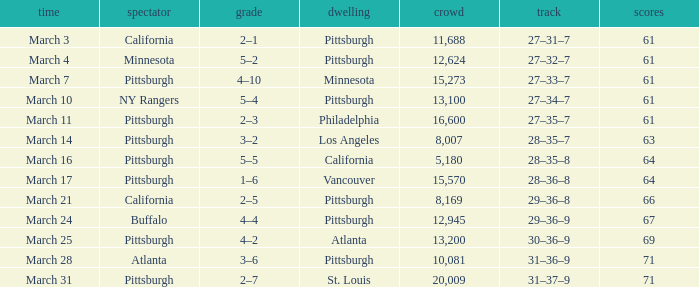What is the Date of the game in Vancouver? March 17. 